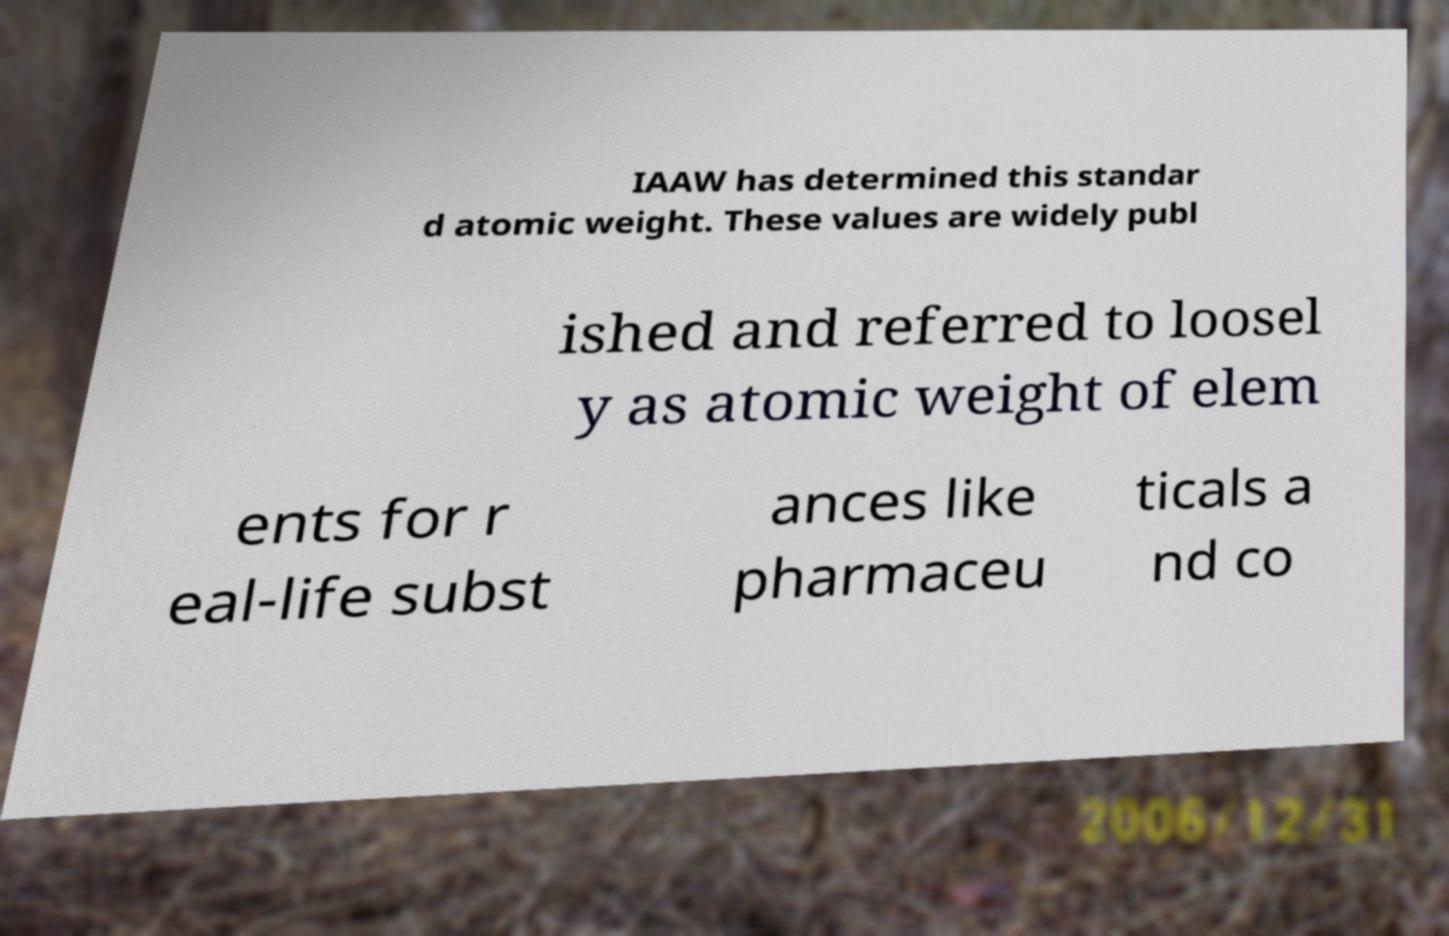Could you assist in decoding the text presented in this image and type it out clearly? IAAW has determined this standar d atomic weight. These values are widely publ ished and referred to loosel y as atomic weight of elem ents for r eal-life subst ances like pharmaceu ticals a nd co 